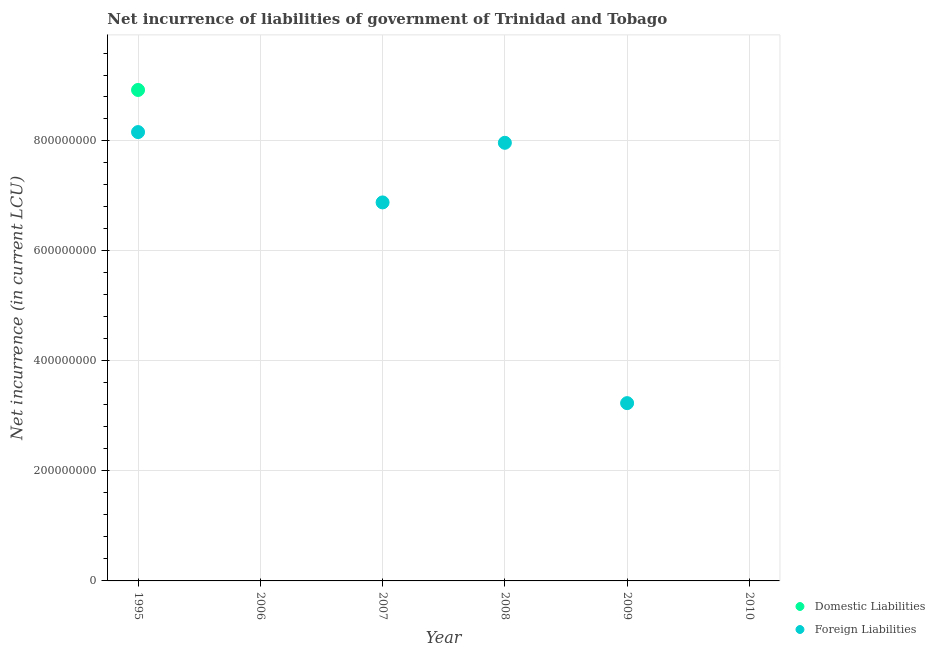How many different coloured dotlines are there?
Ensure brevity in your answer.  2. What is the net incurrence of domestic liabilities in 2009?
Keep it short and to the point. 0. Across all years, what is the maximum net incurrence of domestic liabilities?
Provide a short and direct response. 8.93e+08. Across all years, what is the minimum net incurrence of domestic liabilities?
Provide a succinct answer. 0. In which year was the net incurrence of domestic liabilities maximum?
Provide a succinct answer. 1995. What is the total net incurrence of foreign liabilities in the graph?
Ensure brevity in your answer.  2.62e+09. What is the difference between the net incurrence of domestic liabilities in 1995 and the net incurrence of foreign liabilities in 2008?
Give a very brief answer. 9.61e+07. What is the average net incurrence of foreign liabilities per year?
Ensure brevity in your answer.  4.37e+08. In the year 1995, what is the difference between the net incurrence of foreign liabilities and net incurrence of domestic liabilities?
Offer a very short reply. -7.66e+07. In how many years, is the net incurrence of foreign liabilities greater than 880000000 LCU?
Provide a short and direct response. 0. What is the ratio of the net incurrence of foreign liabilities in 2007 to that in 2009?
Provide a short and direct response. 2.13. Is the net incurrence of foreign liabilities in 1995 less than that in 2007?
Keep it short and to the point. No. What is the difference between the highest and the second highest net incurrence of foreign liabilities?
Provide a short and direct response. 1.95e+07. What is the difference between the highest and the lowest net incurrence of foreign liabilities?
Your answer should be very brief. 8.16e+08. In how many years, is the net incurrence of foreign liabilities greater than the average net incurrence of foreign liabilities taken over all years?
Provide a succinct answer. 3. Is the sum of the net incurrence of foreign liabilities in 1995 and 2009 greater than the maximum net incurrence of domestic liabilities across all years?
Your answer should be compact. Yes. Does the net incurrence of foreign liabilities monotonically increase over the years?
Ensure brevity in your answer.  No. How many years are there in the graph?
Keep it short and to the point. 6. What is the difference between two consecutive major ticks on the Y-axis?
Your answer should be very brief. 2.00e+08. Are the values on the major ticks of Y-axis written in scientific E-notation?
Offer a very short reply. No. What is the title of the graph?
Keep it short and to the point. Net incurrence of liabilities of government of Trinidad and Tobago. Does "National Tourists" appear as one of the legend labels in the graph?
Your answer should be very brief. No. What is the label or title of the Y-axis?
Your response must be concise. Net incurrence (in current LCU). What is the Net incurrence (in current LCU) in Domestic Liabilities in 1995?
Ensure brevity in your answer.  8.93e+08. What is the Net incurrence (in current LCU) of Foreign Liabilities in 1995?
Your answer should be very brief. 8.16e+08. What is the Net incurrence (in current LCU) of Domestic Liabilities in 2006?
Keep it short and to the point. 0. What is the Net incurrence (in current LCU) of Foreign Liabilities in 2006?
Your answer should be very brief. 0. What is the Net incurrence (in current LCU) in Domestic Liabilities in 2007?
Keep it short and to the point. 0. What is the Net incurrence (in current LCU) in Foreign Liabilities in 2007?
Provide a short and direct response. 6.88e+08. What is the Net incurrence (in current LCU) in Domestic Liabilities in 2008?
Provide a short and direct response. 0. What is the Net incurrence (in current LCU) in Foreign Liabilities in 2008?
Your response must be concise. 7.97e+08. What is the Net incurrence (in current LCU) of Foreign Liabilities in 2009?
Your response must be concise. 3.23e+08. What is the Net incurrence (in current LCU) in Foreign Liabilities in 2010?
Offer a terse response. 0. Across all years, what is the maximum Net incurrence (in current LCU) of Domestic Liabilities?
Ensure brevity in your answer.  8.93e+08. Across all years, what is the maximum Net incurrence (in current LCU) in Foreign Liabilities?
Make the answer very short. 8.16e+08. What is the total Net incurrence (in current LCU) of Domestic Liabilities in the graph?
Your answer should be compact. 8.93e+08. What is the total Net incurrence (in current LCU) in Foreign Liabilities in the graph?
Your answer should be compact. 2.62e+09. What is the difference between the Net incurrence (in current LCU) in Foreign Liabilities in 1995 and that in 2007?
Give a very brief answer. 1.28e+08. What is the difference between the Net incurrence (in current LCU) of Foreign Liabilities in 1995 and that in 2008?
Your answer should be very brief. 1.95e+07. What is the difference between the Net incurrence (in current LCU) of Foreign Liabilities in 1995 and that in 2009?
Your response must be concise. 4.93e+08. What is the difference between the Net incurrence (in current LCU) in Foreign Liabilities in 2007 and that in 2008?
Provide a succinct answer. -1.08e+08. What is the difference between the Net incurrence (in current LCU) of Foreign Liabilities in 2007 and that in 2009?
Offer a terse response. 3.65e+08. What is the difference between the Net incurrence (in current LCU) in Foreign Liabilities in 2008 and that in 2009?
Your answer should be very brief. 4.73e+08. What is the difference between the Net incurrence (in current LCU) in Domestic Liabilities in 1995 and the Net incurrence (in current LCU) in Foreign Liabilities in 2007?
Provide a short and direct response. 2.04e+08. What is the difference between the Net incurrence (in current LCU) in Domestic Liabilities in 1995 and the Net incurrence (in current LCU) in Foreign Liabilities in 2008?
Keep it short and to the point. 9.61e+07. What is the difference between the Net incurrence (in current LCU) of Domestic Liabilities in 1995 and the Net incurrence (in current LCU) of Foreign Liabilities in 2009?
Your answer should be compact. 5.70e+08. What is the average Net incurrence (in current LCU) of Domestic Liabilities per year?
Provide a succinct answer. 1.49e+08. What is the average Net incurrence (in current LCU) in Foreign Liabilities per year?
Offer a terse response. 4.37e+08. In the year 1995, what is the difference between the Net incurrence (in current LCU) in Domestic Liabilities and Net incurrence (in current LCU) in Foreign Liabilities?
Provide a short and direct response. 7.66e+07. What is the ratio of the Net incurrence (in current LCU) in Foreign Liabilities in 1995 to that in 2007?
Offer a terse response. 1.19. What is the ratio of the Net incurrence (in current LCU) of Foreign Liabilities in 1995 to that in 2008?
Give a very brief answer. 1.02. What is the ratio of the Net incurrence (in current LCU) in Foreign Liabilities in 1995 to that in 2009?
Your answer should be very brief. 2.52. What is the ratio of the Net incurrence (in current LCU) of Foreign Liabilities in 2007 to that in 2008?
Offer a terse response. 0.86. What is the ratio of the Net incurrence (in current LCU) of Foreign Liabilities in 2007 to that in 2009?
Ensure brevity in your answer.  2.13. What is the ratio of the Net incurrence (in current LCU) in Foreign Liabilities in 2008 to that in 2009?
Provide a succinct answer. 2.46. What is the difference between the highest and the second highest Net incurrence (in current LCU) in Foreign Liabilities?
Offer a very short reply. 1.95e+07. What is the difference between the highest and the lowest Net incurrence (in current LCU) of Domestic Liabilities?
Your answer should be very brief. 8.93e+08. What is the difference between the highest and the lowest Net incurrence (in current LCU) of Foreign Liabilities?
Offer a terse response. 8.16e+08. 